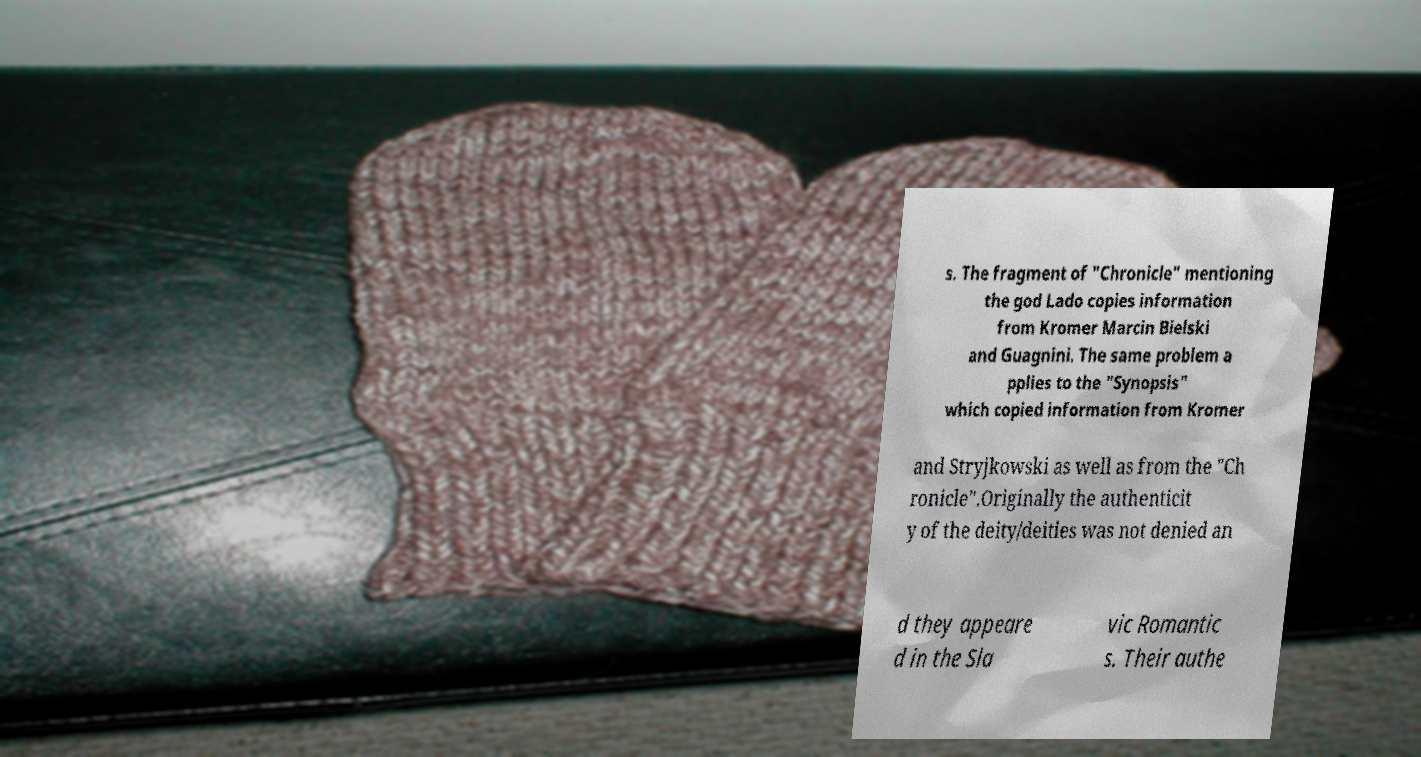What messages or text are displayed in this image? I need them in a readable, typed format. s. The fragment of "Chronicle" mentioning the god Lado copies information from Kromer Marcin Bielski and Guagnini. The same problem a pplies to the "Synopsis" which copied information from Kromer and Stryjkowski as well as from the "Ch ronicle".Originally the authenticit y of the deity/deities was not denied an d they appeare d in the Sla vic Romantic s. Their authe 